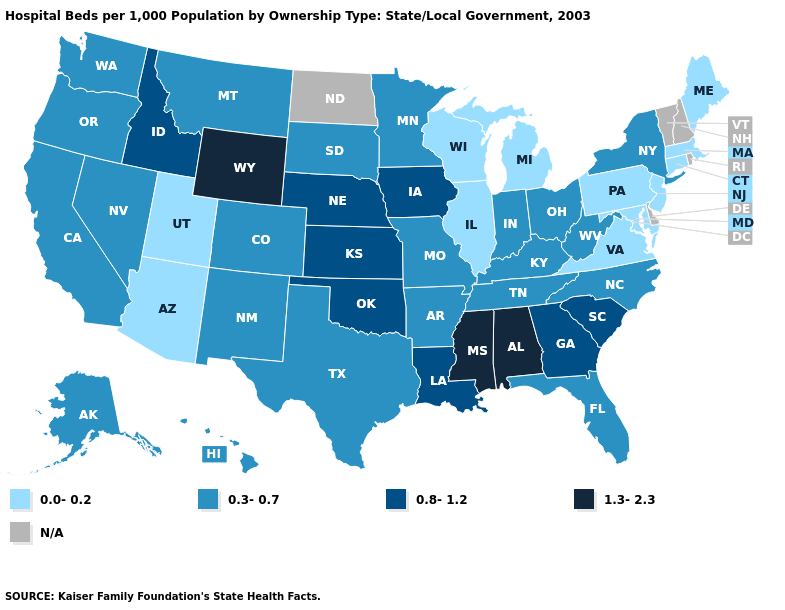Which states hav the highest value in the South?
Write a very short answer. Alabama, Mississippi. Name the states that have a value in the range 0.8-1.2?
Answer briefly. Georgia, Idaho, Iowa, Kansas, Louisiana, Nebraska, Oklahoma, South Carolina. What is the value of Arizona?
Concise answer only. 0.0-0.2. What is the highest value in states that border North Carolina?
Answer briefly. 0.8-1.2. What is the highest value in the South ?
Quick response, please. 1.3-2.3. Name the states that have a value in the range 0.8-1.2?
Concise answer only. Georgia, Idaho, Iowa, Kansas, Louisiana, Nebraska, Oklahoma, South Carolina. What is the value of South Dakota?
Short answer required. 0.3-0.7. What is the value of Delaware?
Write a very short answer. N/A. Among the states that border Kentucky , which have the highest value?
Write a very short answer. Indiana, Missouri, Ohio, Tennessee, West Virginia. Does New York have the lowest value in the Northeast?
Be succinct. No. Does the first symbol in the legend represent the smallest category?
Keep it brief. Yes. Does the first symbol in the legend represent the smallest category?
Answer briefly. Yes. What is the lowest value in states that border Colorado?
Write a very short answer. 0.0-0.2. Among the states that border Wyoming , does Idaho have the lowest value?
Short answer required. No. What is the highest value in the South ?
Give a very brief answer. 1.3-2.3. 